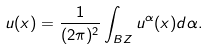<formula> <loc_0><loc_0><loc_500><loc_500>u ( x ) = \frac { 1 } { ( 2 \pi ) ^ { 2 } } \int _ { B Z } u ^ { \alpha } ( x ) d \alpha .</formula> 